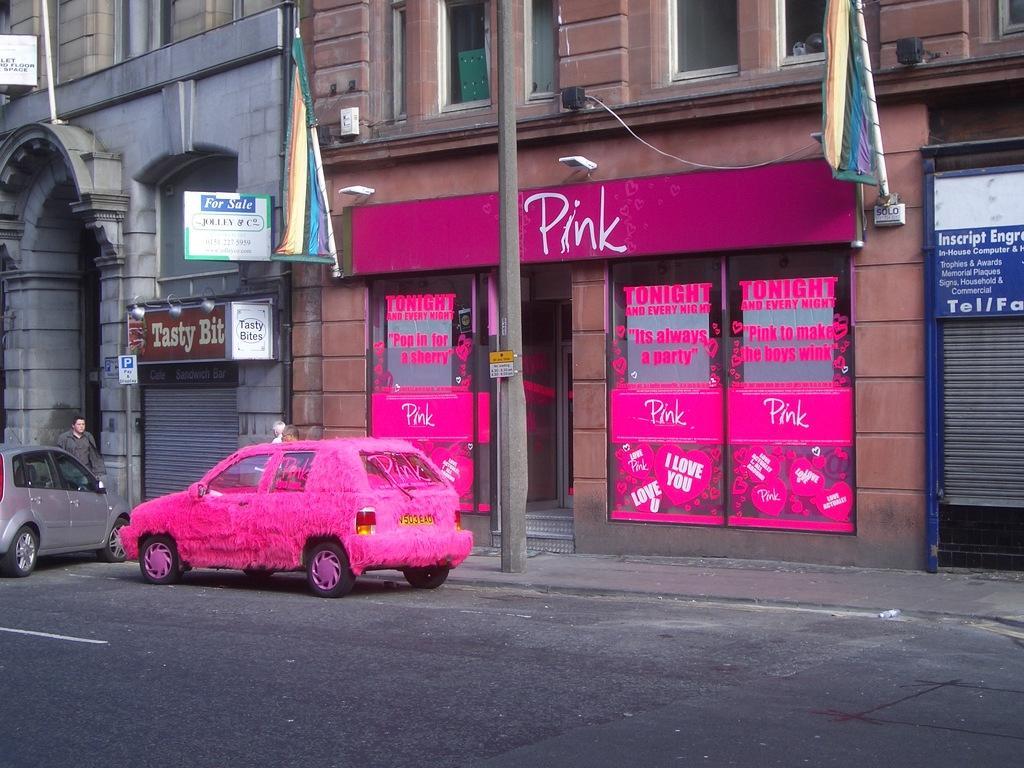In one or two sentences, can you explain what this image depicts? In this picture we can see a pink car and another car parked on the road in front of a store with pink stickers on the window. In the background, we can see a person, buildings, windows, poles and shutters. 